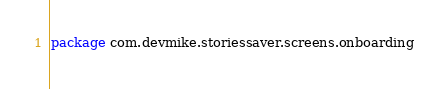<code> <loc_0><loc_0><loc_500><loc_500><_Kotlin_>package com.devmike.storiessaver.screens.onboarding

</code> 